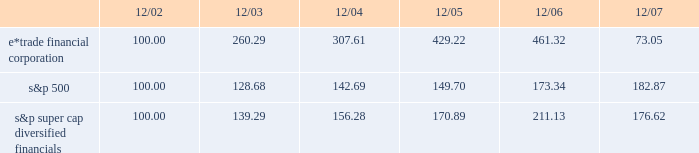December 18 , 2007 , we issued an additional 23182197 shares of common stock to citadel .
The issuances were exempt from registration pursuant to section 4 ( 2 ) of the securities act of 1933 , and each purchaser has represented to us that it is an 201caccredited investor 201d as defined in regulation d promulgated under the securities act of 1933 , and that the common stock was being acquired for investment .
We did not engage in a general solicitation or advertising with regard to the issuances of the common stock and have not offered securities to the public in connection with the issuances .
See item 1 .
Business 2014citadel investment .
Performance graph the following performance graph shows the cumulative total return to a holder of the company 2019s common stock , assuming dividend reinvestment , compared with the cumulative total return , assuming dividend reinvestment , of the standard & poor 2019s ( 201cs&p 201d ) 500 and the s&p super cap diversified financials during the period from december 31 , 2002 through december 31 , 2007. .
2022 $ 100 invested on 12/31/02 in stock or index-including reinvestment of dividends .
Fiscal year ending december 31 .
2022 copyright a9 2008 , standard & poor 2019s , a division of the mcgraw-hill companies , inc .
All rights reserved .
Www.researchdatagroup.com/s&p.htm .
What was the percent of the growth in the total cumulative value of the common stock for e*trade financial corporation from 2004 to 2005? 
Rationale: the total cumulative value of the common stock for e*trade financial corporation increased by 39.5% from 2004 to 2005
Computations: ((429.22 - 307.61) / 307.61)
Answer: 0.39534. 